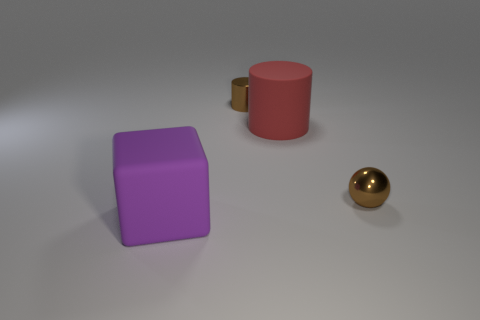There is a purple matte block that is on the left side of the tiny brown thing that is right of the tiny shiny cylinder; what size is it?
Your response must be concise. Large. There is a big object that is on the left side of the object behind the big matte object right of the shiny cylinder; what shape is it?
Give a very brief answer. Cube. There is a purple cube that is the same material as the large red object; what is its size?
Your response must be concise. Large. Is the number of small green metal spheres greater than the number of brown things?
Your answer should be very brief. No. What material is the other thing that is the same size as the red rubber object?
Provide a succinct answer. Rubber. Does the metallic thing behind the red matte cylinder have the same size as the big purple cube?
Your response must be concise. No. What number of spheres are either large purple matte objects or matte things?
Keep it short and to the point. 0. What is the big object in front of the red cylinder made of?
Provide a succinct answer. Rubber. Are there fewer cylinders than balls?
Your answer should be compact. No. There is a thing that is both on the left side of the big red matte thing and on the right side of the large block; what is its size?
Ensure brevity in your answer.  Small. 